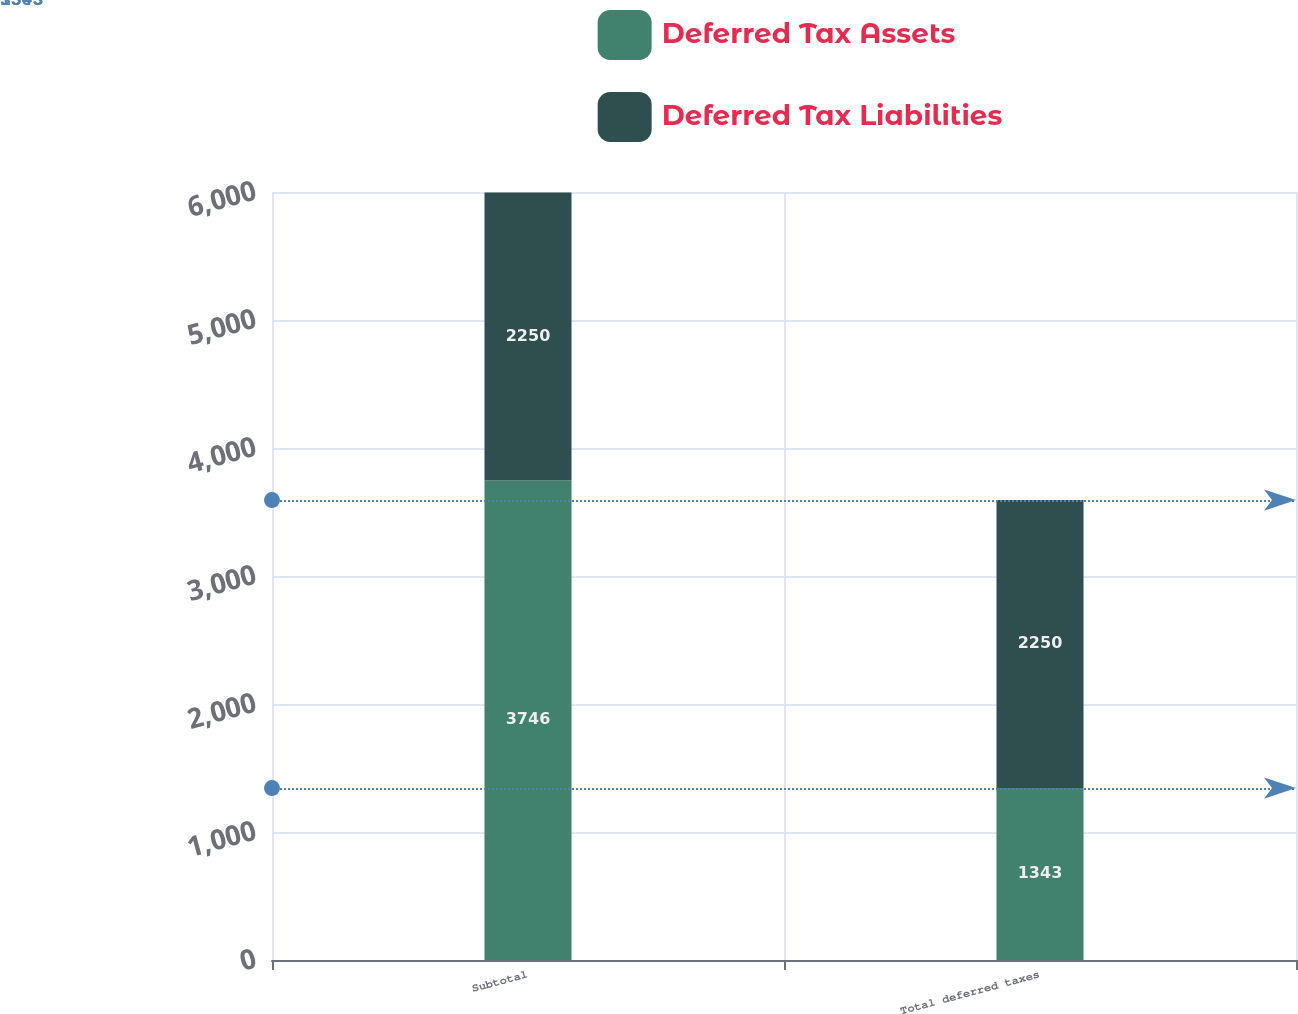Convert chart. <chart><loc_0><loc_0><loc_500><loc_500><stacked_bar_chart><ecel><fcel>Subtotal<fcel>Total deferred taxes<nl><fcel>Deferred Tax Assets<fcel>3746<fcel>1343<nl><fcel>Deferred Tax Liabilities<fcel>2250<fcel>2250<nl></chart> 